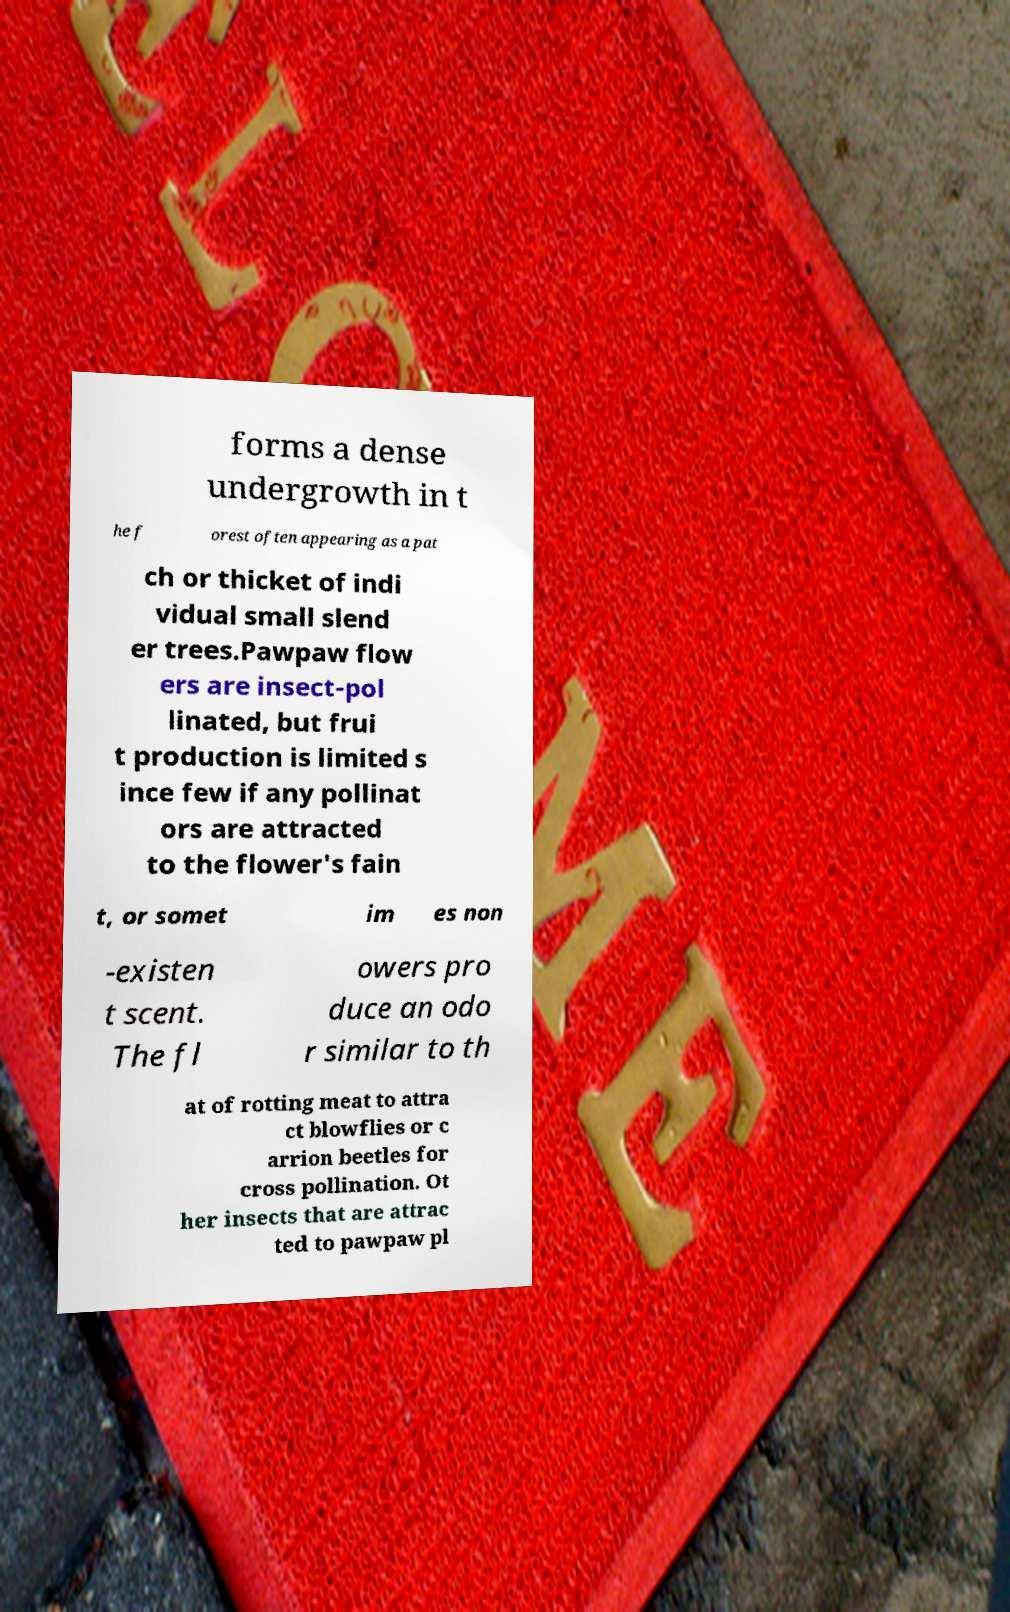Can you accurately transcribe the text from the provided image for me? forms a dense undergrowth in t he f orest often appearing as a pat ch or thicket of indi vidual small slend er trees.Pawpaw flow ers are insect-pol linated, but frui t production is limited s ince few if any pollinat ors are attracted to the flower's fain t, or somet im es non -existen t scent. The fl owers pro duce an odo r similar to th at of rotting meat to attra ct blowflies or c arrion beetles for cross pollination. Ot her insects that are attrac ted to pawpaw pl 